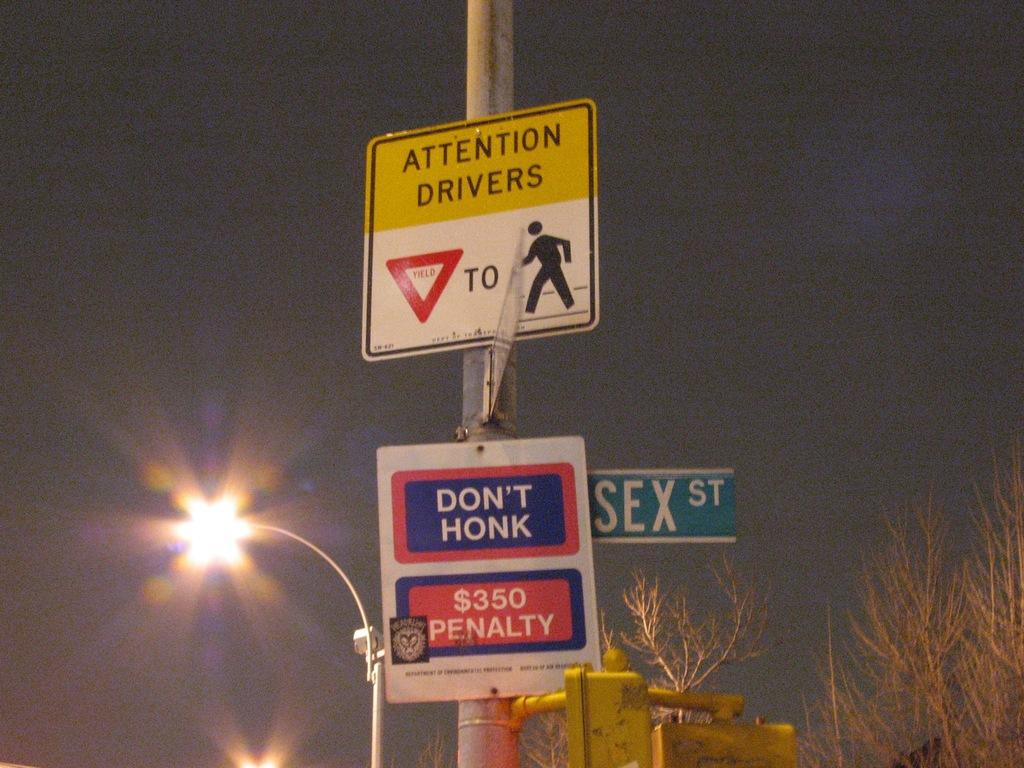What is the penalty amount?
Provide a short and direct response. $350. 